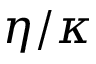<formula> <loc_0><loc_0><loc_500><loc_500>\eta / \kappa</formula> 